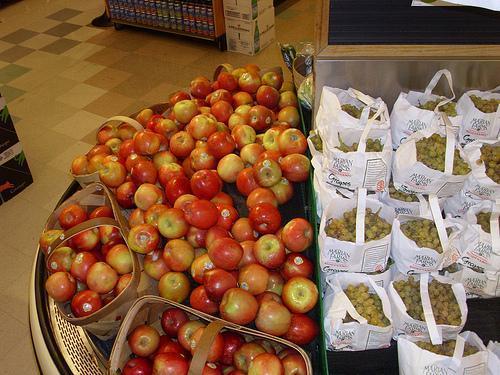How many baskets of apples are in the display?
Give a very brief answer. 4. 